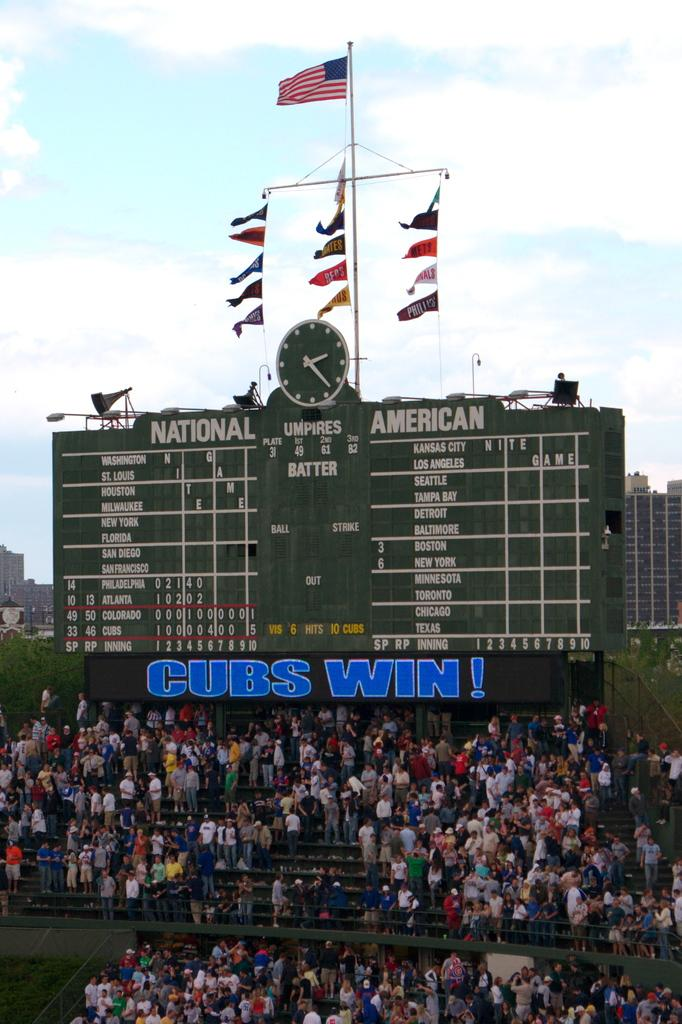<image>
Provide a brief description of the given image. A game score board saying cubs win in blue on it 